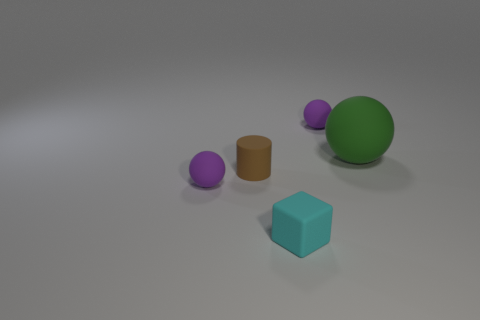Are there any other things that have the same size as the green matte sphere?
Your response must be concise. No. There is a purple object right of the purple object that is in front of the big rubber sphere; how big is it?
Provide a short and direct response. Small. Is there anything else that has the same material as the cylinder?
Your answer should be compact. Yes. Are there more purple matte spheres than objects?
Provide a short and direct response. No. Is the color of the small ball on the right side of the small cube the same as the small sphere in front of the big green thing?
Offer a very short reply. Yes. There is a purple thing to the right of the block; is there a tiny cyan object right of it?
Your response must be concise. No. Is the number of large green matte spheres that are left of the small brown thing less than the number of cubes right of the green rubber ball?
Your answer should be very brief. No. Does the small ball to the right of the tiny cyan object have the same material as the tiny purple thing that is in front of the large sphere?
Provide a succinct answer. Yes. What number of big objects are either purple things or green matte balls?
Your answer should be compact. 1. What is the shape of the other brown object that is made of the same material as the large thing?
Provide a succinct answer. Cylinder. 